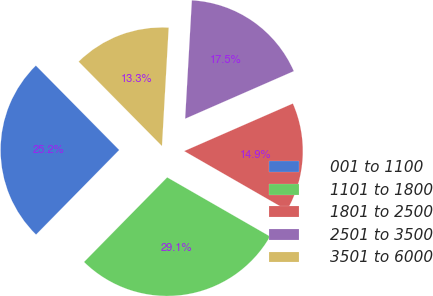Convert chart to OTSL. <chart><loc_0><loc_0><loc_500><loc_500><pie_chart><fcel>001 to 1100<fcel>1101 to 1800<fcel>1801 to 2500<fcel>2501 to 3500<fcel>3501 to 6000<nl><fcel>25.24%<fcel>29.06%<fcel>14.87%<fcel>17.53%<fcel>13.3%<nl></chart> 